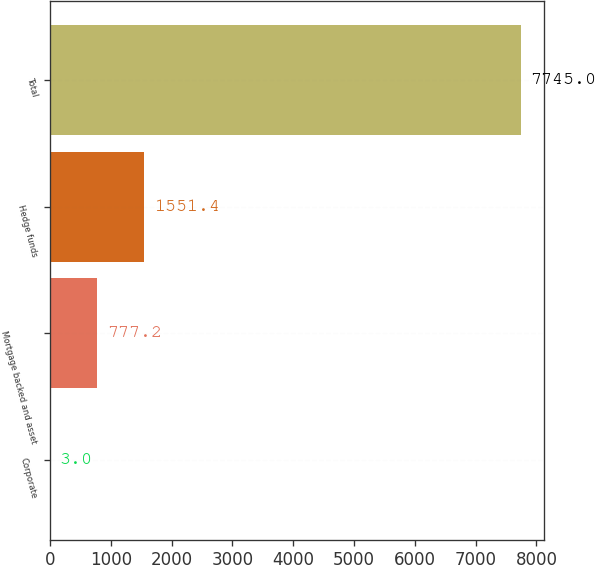Convert chart to OTSL. <chart><loc_0><loc_0><loc_500><loc_500><bar_chart><fcel>Corporate<fcel>Mortgage backed and asset<fcel>Hedge funds<fcel>Total<nl><fcel>3<fcel>777.2<fcel>1551.4<fcel>7745<nl></chart> 